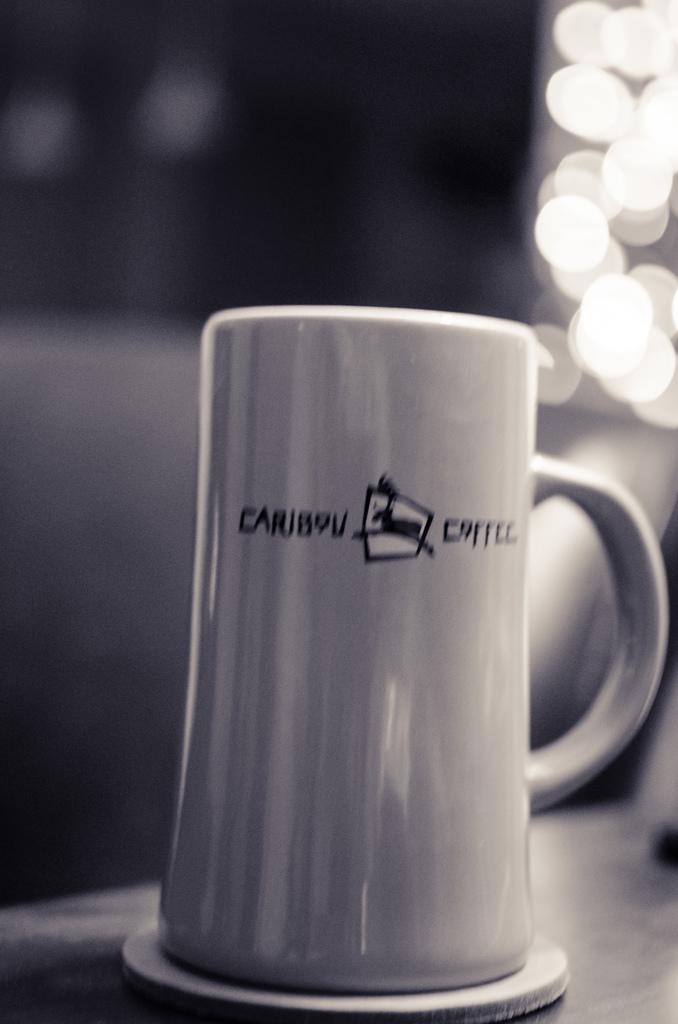<image>
Present a compact description of the photo's key features. upside down caribou coffee cup on a coaster 